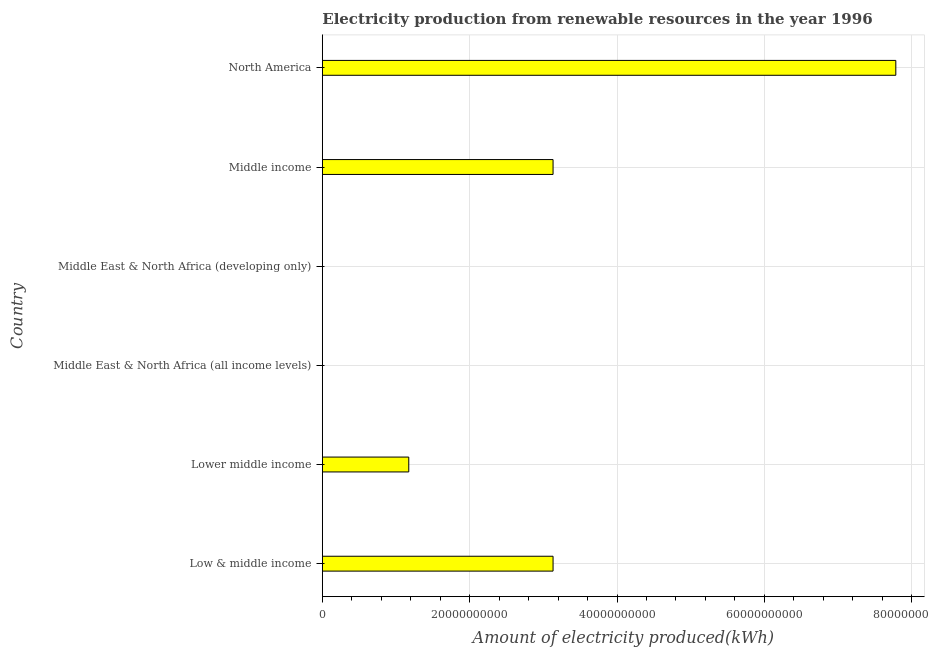What is the title of the graph?
Your response must be concise. Electricity production from renewable resources in the year 1996. What is the label or title of the X-axis?
Make the answer very short. Amount of electricity produced(kWh). What is the label or title of the Y-axis?
Your response must be concise. Country. What is the amount of electricity produced in North America?
Make the answer very short. 7.78e+1. Across all countries, what is the maximum amount of electricity produced?
Your answer should be compact. 7.78e+1. Across all countries, what is the minimum amount of electricity produced?
Ensure brevity in your answer.  1.00e+06. In which country was the amount of electricity produced minimum?
Offer a very short reply. Middle East & North Africa (all income levels). What is the sum of the amount of electricity produced?
Your answer should be compact. 1.52e+11. What is the difference between the amount of electricity produced in Middle East & North Africa (all income levels) and Middle East & North Africa (developing only)?
Provide a short and direct response. 0. What is the average amount of electricity produced per country?
Provide a succinct answer. 2.54e+1. What is the median amount of electricity produced?
Your answer should be compact. 2.15e+1. What is the ratio of the amount of electricity produced in Lower middle income to that in North America?
Your answer should be very brief. 0.15. What is the difference between the highest and the second highest amount of electricity produced?
Provide a succinct answer. 4.65e+1. Is the sum of the amount of electricity produced in Low & middle income and Middle East & North Africa (all income levels) greater than the maximum amount of electricity produced across all countries?
Ensure brevity in your answer.  No. What is the difference between the highest and the lowest amount of electricity produced?
Your answer should be very brief. 7.78e+1. In how many countries, is the amount of electricity produced greater than the average amount of electricity produced taken over all countries?
Your answer should be very brief. 3. How many bars are there?
Keep it short and to the point. 6. What is the difference between two consecutive major ticks on the X-axis?
Your response must be concise. 2.00e+1. Are the values on the major ticks of X-axis written in scientific E-notation?
Offer a very short reply. No. What is the Amount of electricity produced(kWh) of Low & middle income?
Keep it short and to the point. 3.13e+1. What is the Amount of electricity produced(kWh) in Lower middle income?
Offer a terse response. 1.17e+1. What is the Amount of electricity produced(kWh) of Middle East & North Africa (developing only)?
Provide a succinct answer. 1.00e+06. What is the Amount of electricity produced(kWh) of Middle income?
Provide a succinct answer. 3.13e+1. What is the Amount of electricity produced(kWh) in North America?
Offer a very short reply. 7.78e+1. What is the difference between the Amount of electricity produced(kWh) in Low & middle income and Lower middle income?
Give a very brief answer. 1.96e+1. What is the difference between the Amount of electricity produced(kWh) in Low & middle income and Middle East & North Africa (all income levels)?
Your response must be concise. 3.13e+1. What is the difference between the Amount of electricity produced(kWh) in Low & middle income and Middle East & North Africa (developing only)?
Your answer should be very brief. 3.13e+1. What is the difference between the Amount of electricity produced(kWh) in Low & middle income and North America?
Ensure brevity in your answer.  -4.65e+1. What is the difference between the Amount of electricity produced(kWh) in Lower middle income and Middle East & North Africa (all income levels)?
Your answer should be very brief. 1.17e+1. What is the difference between the Amount of electricity produced(kWh) in Lower middle income and Middle East & North Africa (developing only)?
Keep it short and to the point. 1.17e+1. What is the difference between the Amount of electricity produced(kWh) in Lower middle income and Middle income?
Ensure brevity in your answer.  -1.96e+1. What is the difference between the Amount of electricity produced(kWh) in Lower middle income and North America?
Make the answer very short. -6.61e+1. What is the difference between the Amount of electricity produced(kWh) in Middle East & North Africa (all income levels) and Middle income?
Your answer should be compact. -3.13e+1. What is the difference between the Amount of electricity produced(kWh) in Middle East & North Africa (all income levels) and North America?
Make the answer very short. -7.78e+1. What is the difference between the Amount of electricity produced(kWh) in Middle East & North Africa (developing only) and Middle income?
Ensure brevity in your answer.  -3.13e+1. What is the difference between the Amount of electricity produced(kWh) in Middle East & North Africa (developing only) and North America?
Make the answer very short. -7.78e+1. What is the difference between the Amount of electricity produced(kWh) in Middle income and North America?
Provide a short and direct response. -4.65e+1. What is the ratio of the Amount of electricity produced(kWh) in Low & middle income to that in Lower middle income?
Provide a short and direct response. 2.67. What is the ratio of the Amount of electricity produced(kWh) in Low & middle income to that in Middle East & North Africa (all income levels)?
Your answer should be very brief. 3.13e+04. What is the ratio of the Amount of electricity produced(kWh) in Low & middle income to that in Middle East & North Africa (developing only)?
Offer a terse response. 3.13e+04. What is the ratio of the Amount of electricity produced(kWh) in Low & middle income to that in Middle income?
Keep it short and to the point. 1. What is the ratio of the Amount of electricity produced(kWh) in Low & middle income to that in North America?
Ensure brevity in your answer.  0.4. What is the ratio of the Amount of electricity produced(kWh) in Lower middle income to that in Middle East & North Africa (all income levels)?
Offer a terse response. 1.17e+04. What is the ratio of the Amount of electricity produced(kWh) in Lower middle income to that in Middle East & North Africa (developing only)?
Offer a terse response. 1.17e+04. What is the ratio of the Amount of electricity produced(kWh) in Lower middle income to that in North America?
Your response must be concise. 0.15. What is the ratio of the Amount of electricity produced(kWh) in Middle East & North Africa (all income levels) to that in Middle income?
Keep it short and to the point. 0. What is the ratio of the Amount of electricity produced(kWh) in Middle East & North Africa (all income levels) to that in North America?
Make the answer very short. 0. What is the ratio of the Amount of electricity produced(kWh) in Middle East & North Africa (developing only) to that in Middle income?
Make the answer very short. 0. What is the ratio of the Amount of electricity produced(kWh) in Middle East & North Africa (developing only) to that in North America?
Provide a succinct answer. 0. What is the ratio of the Amount of electricity produced(kWh) in Middle income to that in North America?
Offer a terse response. 0.4. 